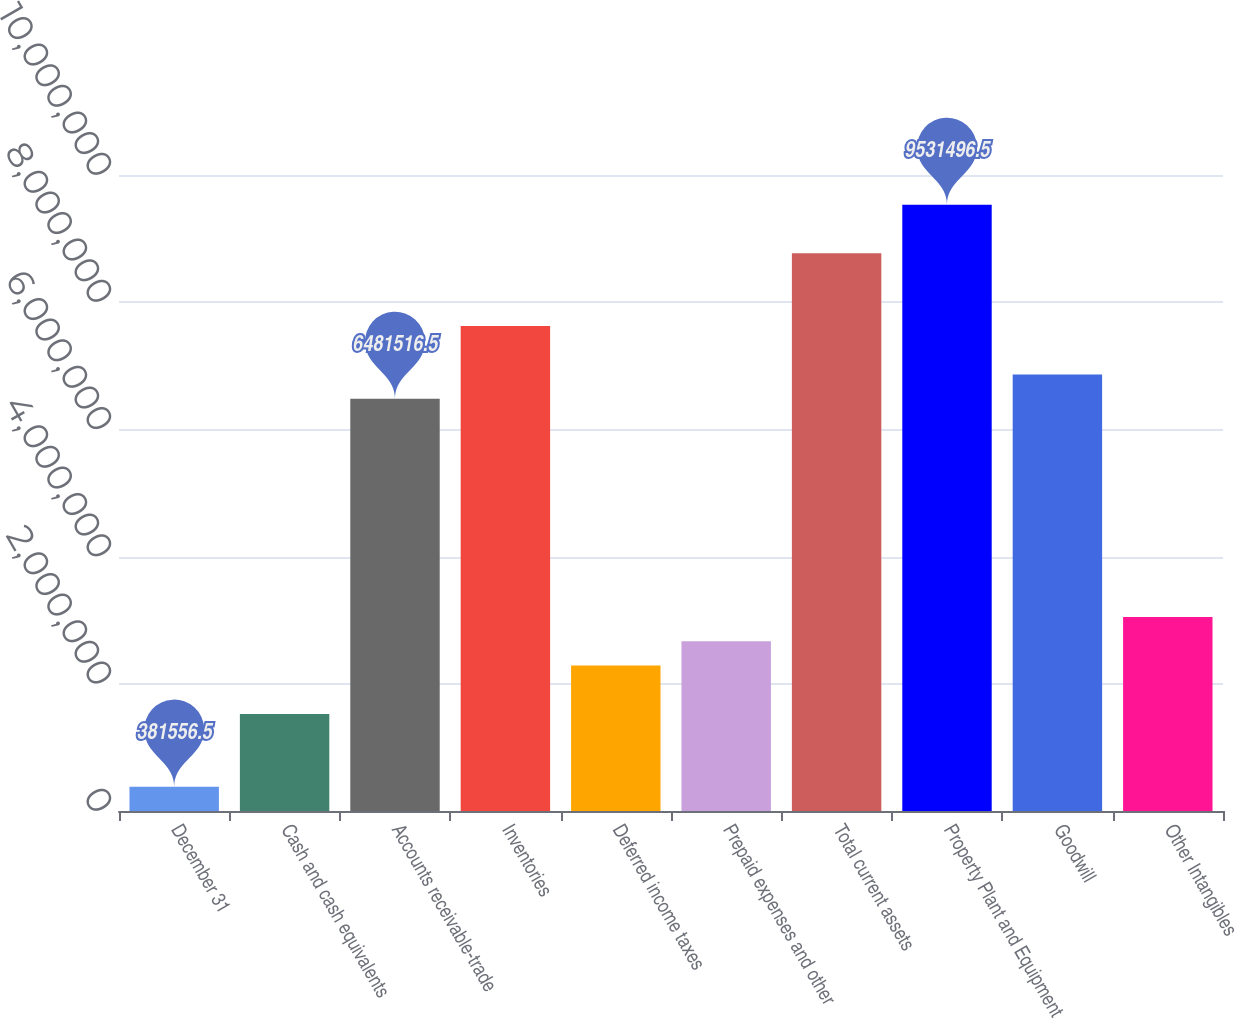Convert chart to OTSL. <chart><loc_0><loc_0><loc_500><loc_500><bar_chart><fcel>December 31<fcel>Cash and cash equivalents<fcel>Accounts receivable-trade<fcel>Inventories<fcel>Deferred income taxes<fcel>Prepaid expenses and other<fcel>Total current assets<fcel>Property Plant and Equipment<fcel>Goodwill<fcel>Other Intangibles<nl><fcel>381556<fcel>1.5253e+06<fcel>6.48152e+06<fcel>7.62526e+06<fcel>2.28779e+06<fcel>2.66904e+06<fcel>8.769e+06<fcel>9.5315e+06<fcel>6.86276e+06<fcel>3.05029e+06<nl></chart> 